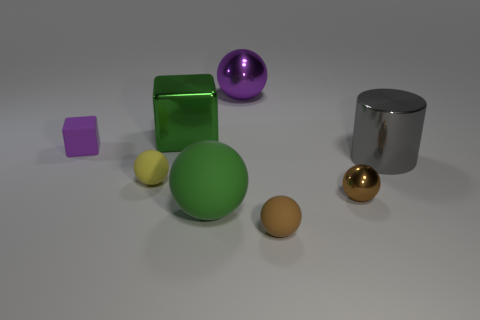Subtract all green spheres. How many spheres are left? 4 Subtract all green balls. How many balls are left? 4 Subtract 3 balls. How many balls are left? 2 Subtract all red balls. Subtract all brown cylinders. How many balls are left? 5 Add 1 tiny green cubes. How many objects exist? 9 Subtract all balls. How many objects are left? 3 Subtract all big green objects. Subtract all brown things. How many objects are left? 4 Add 6 tiny brown rubber balls. How many tiny brown rubber balls are left? 7 Add 5 big metal cubes. How many big metal cubes exist? 6 Subtract 1 yellow balls. How many objects are left? 7 